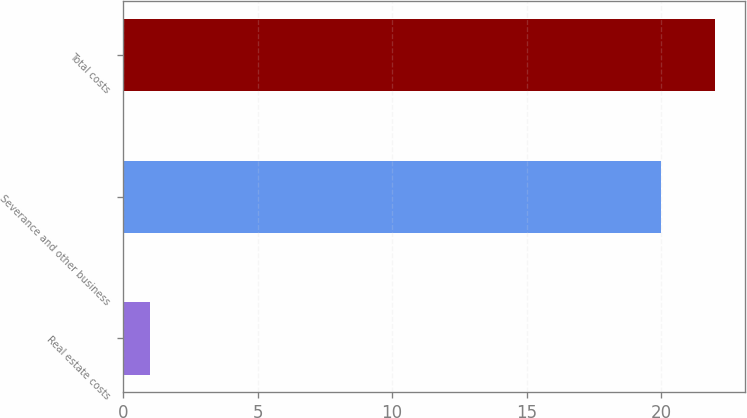Convert chart. <chart><loc_0><loc_0><loc_500><loc_500><bar_chart><fcel>Real estate costs<fcel>Severance and other business<fcel>Total costs<nl><fcel>1<fcel>20<fcel>22<nl></chart> 